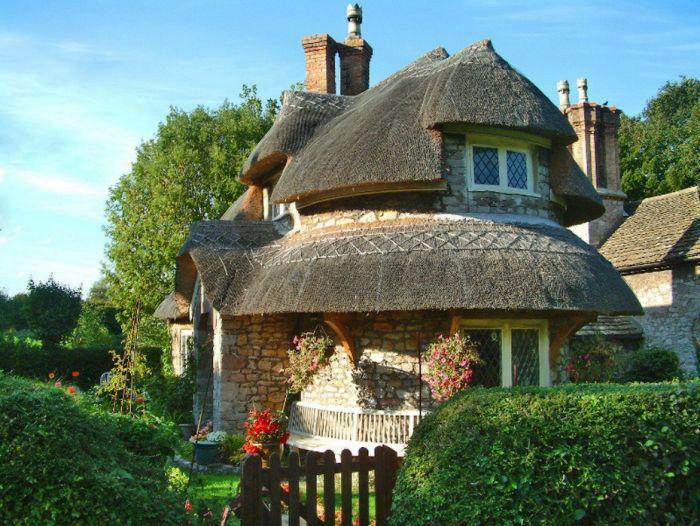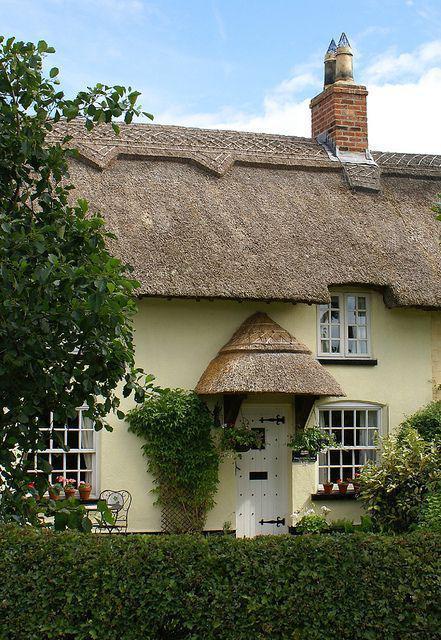The first image is the image on the left, the second image is the image on the right. Considering the images on both sides, is "The left image shows the front of a white house with bold dark lines on it forming geometric patterns, a chimney on at least one end, and a thick grayish peaked roof with a sculptural border along the top edge." valid? Answer yes or no. No. The first image is the image on the left, the second image is the image on the right. Considering the images on both sides, is "In at least one image there is a white house with black stripes of wood that create a box look." valid? Answer yes or no. No. 